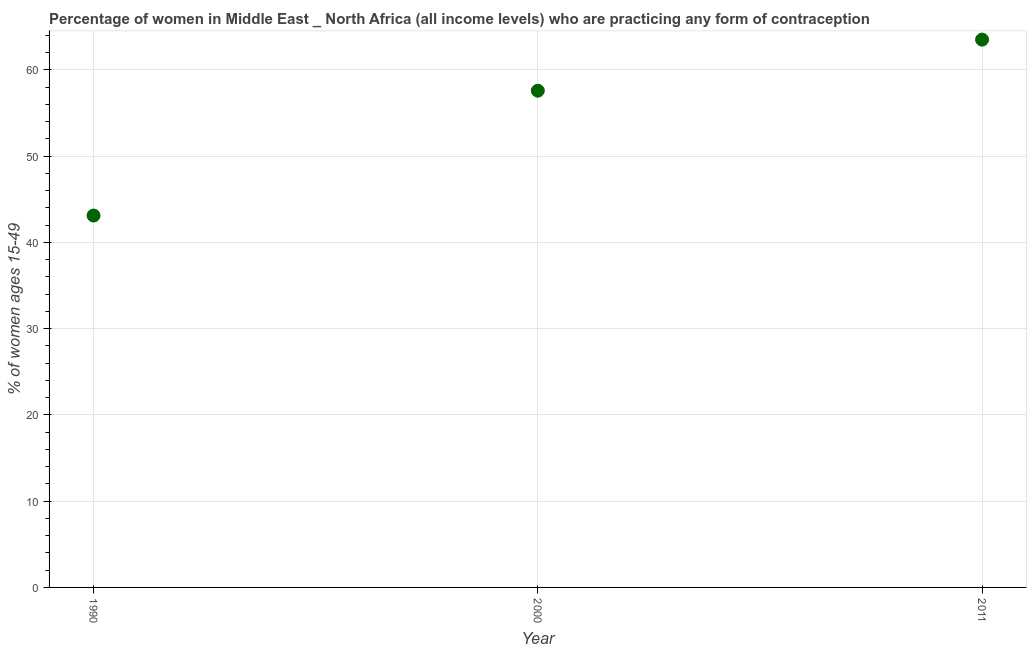What is the contraceptive prevalence in 1990?
Offer a very short reply. 43.12. Across all years, what is the maximum contraceptive prevalence?
Keep it short and to the point. 63.52. Across all years, what is the minimum contraceptive prevalence?
Provide a succinct answer. 43.12. In which year was the contraceptive prevalence minimum?
Provide a succinct answer. 1990. What is the sum of the contraceptive prevalence?
Provide a short and direct response. 164.24. What is the difference between the contraceptive prevalence in 1990 and 2011?
Offer a terse response. -20.4. What is the average contraceptive prevalence per year?
Keep it short and to the point. 54.75. What is the median contraceptive prevalence?
Keep it short and to the point. 57.6. In how many years, is the contraceptive prevalence greater than 60 %?
Give a very brief answer. 1. What is the ratio of the contraceptive prevalence in 1990 to that in 2000?
Provide a short and direct response. 0.75. Is the contraceptive prevalence in 2000 less than that in 2011?
Your response must be concise. Yes. What is the difference between the highest and the second highest contraceptive prevalence?
Ensure brevity in your answer.  5.92. What is the difference between the highest and the lowest contraceptive prevalence?
Give a very brief answer. 20.4. In how many years, is the contraceptive prevalence greater than the average contraceptive prevalence taken over all years?
Your response must be concise. 2. Does the contraceptive prevalence monotonically increase over the years?
Provide a short and direct response. Yes. What is the difference between two consecutive major ticks on the Y-axis?
Your answer should be very brief. 10. What is the title of the graph?
Your answer should be compact. Percentage of women in Middle East _ North Africa (all income levels) who are practicing any form of contraception. What is the label or title of the X-axis?
Ensure brevity in your answer.  Year. What is the label or title of the Y-axis?
Provide a short and direct response. % of women ages 15-49. What is the % of women ages 15-49 in 1990?
Provide a short and direct response. 43.12. What is the % of women ages 15-49 in 2000?
Ensure brevity in your answer.  57.6. What is the % of women ages 15-49 in 2011?
Make the answer very short. 63.52. What is the difference between the % of women ages 15-49 in 1990 and 2000?
Your answer should be very brief. -14.48. What is the difference between the % of women ages 15-49 in 1990 and 2011?
Provide a succinct answer. -20.4. What is the difference between the % of women ages 15-49 in 2000 and 2011?
Make the answer very short. -5.92. What is the ratio of the % of women ages 15-49 in 1990 to that in 2000?
Your response must be concise. 0.75. What is the ratio of the % of women ages 15-49 in 1990 to that in 2011?
Offer a terse response. 0.68. What is the ratio of the % of women ages 15-49 in 2000 to that in 2011?
Provide a short and direct response. 0.91. 